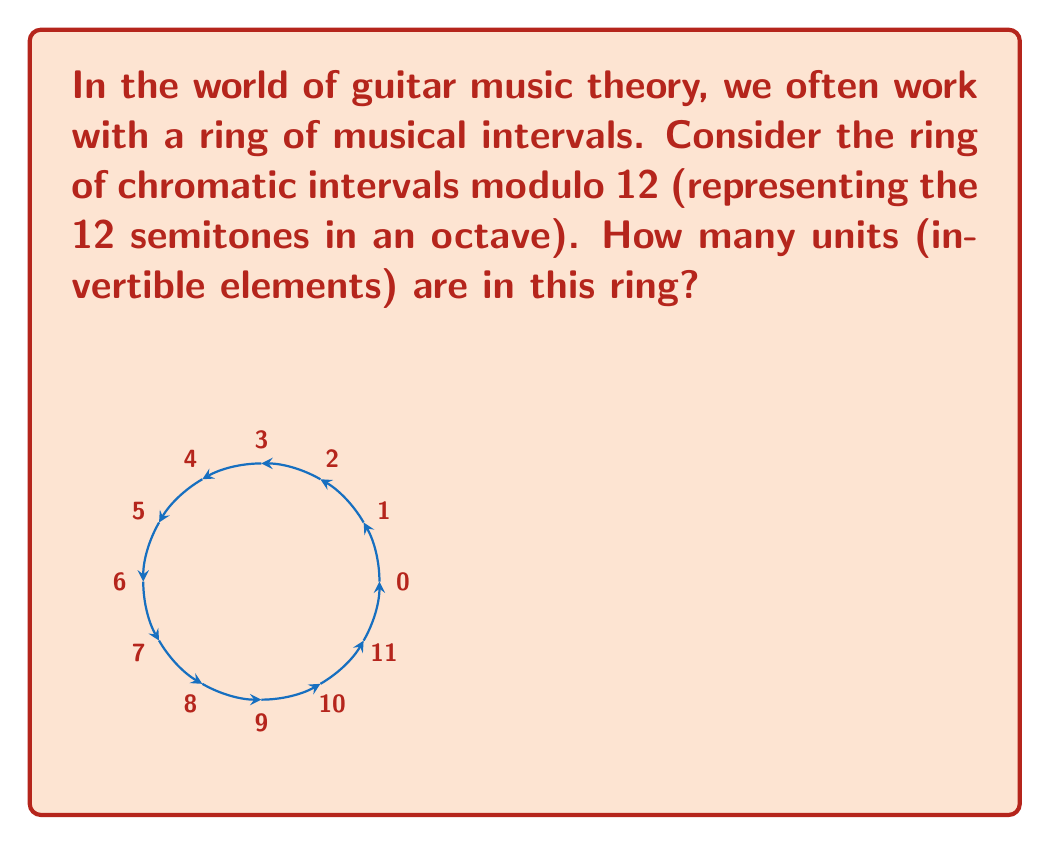Help me with this question. Let's approach this step-by-step:

1) In ring theory, a unit is an element that has a multiplicative inverse.

2) In the ring of integers modulo 12, $\mathbb{Z}_{12}$, an element $a$ is a unit if and only if it is coprime to 12.

3) To find the coprime numbers to 12 in this ring, we need to check which numbers from 1 to 11 have no common factors with 12 other than 1.

4) Let's check each number:
   1 - coprime to 12
   2 - not coprime (shares factor 2)
   3 - not coprime (shares factor 3)
   4 - not coprime (shares factor 2)
   5 - coprime to 12
   7 - coprime to 12
   8 - not coprime (shares factor 2)
   9 - not coprime (shares factor 3)
   10 - not coprime (shares factor 2)
   11 - coprime to 12

5) We found that 1, 5, 7, and 11 are coprime to 12.

6) Therefore, there are 4 units in this ring.

In musical terms, these units correspond to intervals that, when repeated, will cycle through all 12 notes before returning to the starting note: the minor second (1 semitone), perfect fourth (5 semitones), perfect fifth (7 semitones), and major seventh (11 semitones).
Answer: 4 